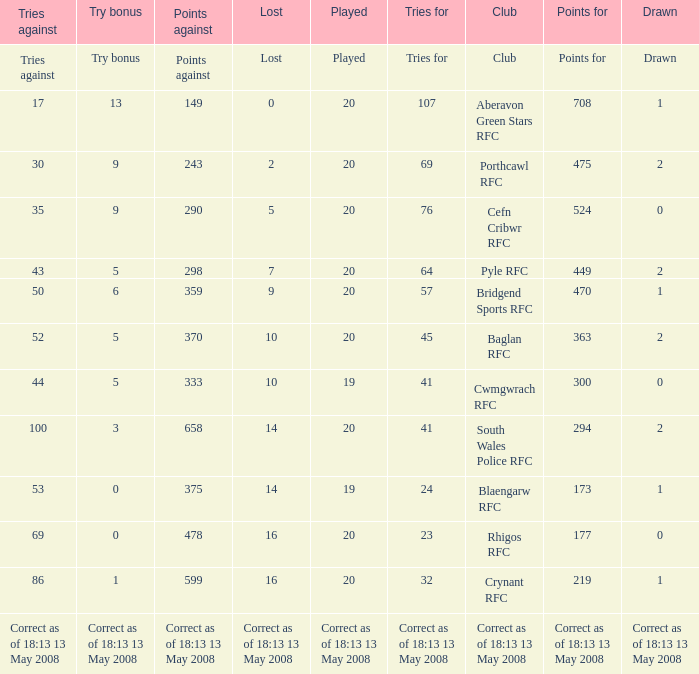What club has a played number of 19, and the lost of 14? Blaengarw RFC. 